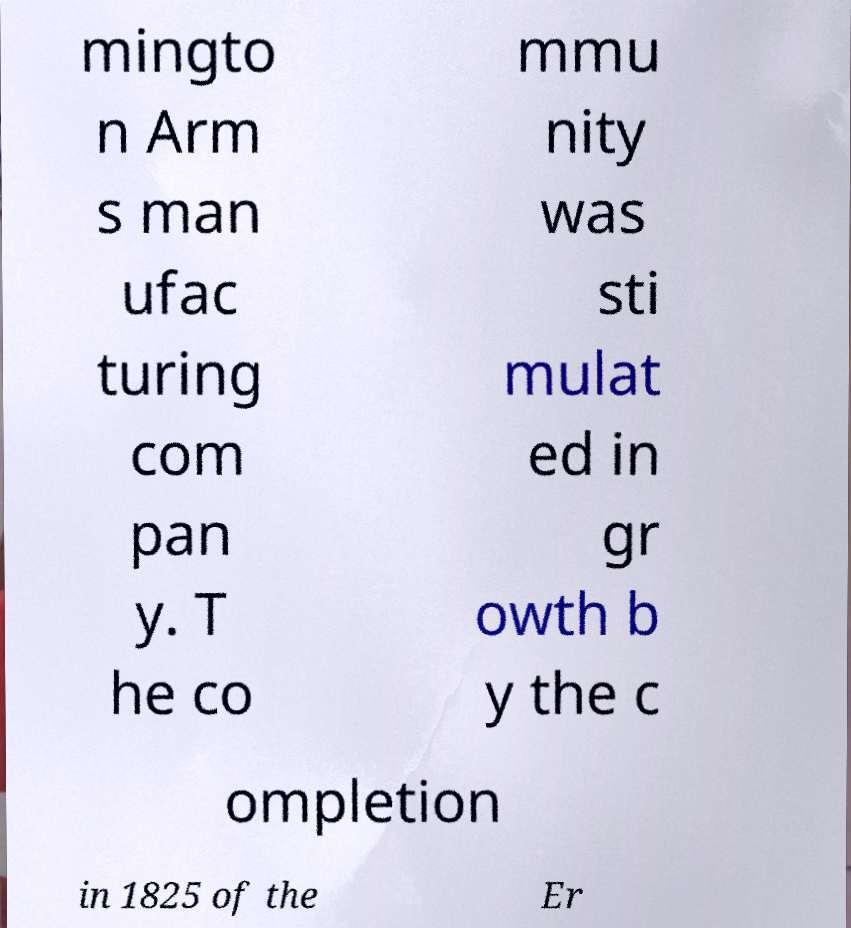Please identify and transcribe the text found in this image. mingto n Arm s man ufac turing com pan y. T he co mmu nity was sti mulat ed in gr owth b y the c ompletion in 1825 of the Er 